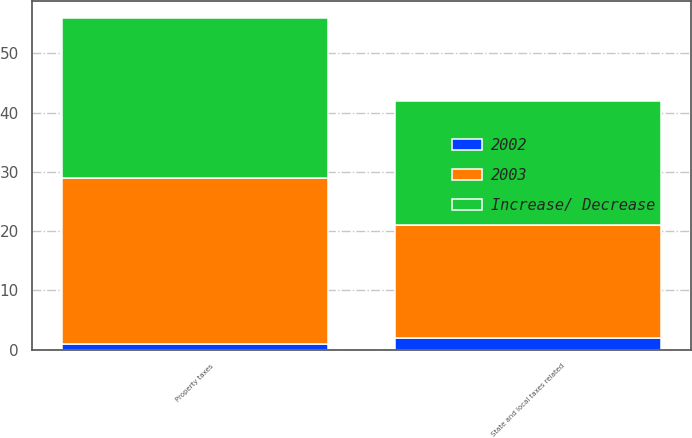<chart> <loc_0><loc_0><loc_500><loc_500><stacked_bar_chart><ecel><fcel>Property taxes<fcel>State and local taxes related<nl><fcel>2003<fcel>28<fcel>19<nl><fcel>Increase/ Decrease<fcel>27<fcel>21<nl><fcel>2002<fcel>1<fcel>2<nl></chart> 